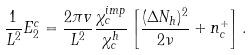<formula> <loc_0><loc_0><loc_500><loc_500>\frac { 1 } { L ^ { 2 } } E _ { 2 } ^ { c } = \frac { 2 \pi v } { L ^ { 2 } } \frac { \chi _ { c } ^ { i m p } } { \chi _ { c } ^ { h } } \left [ \frac { ( \Delta N _ { h } ) ^ { 2 } } { 2 \nu } + n ^ { + } _ { c } \right ] .</formula> 